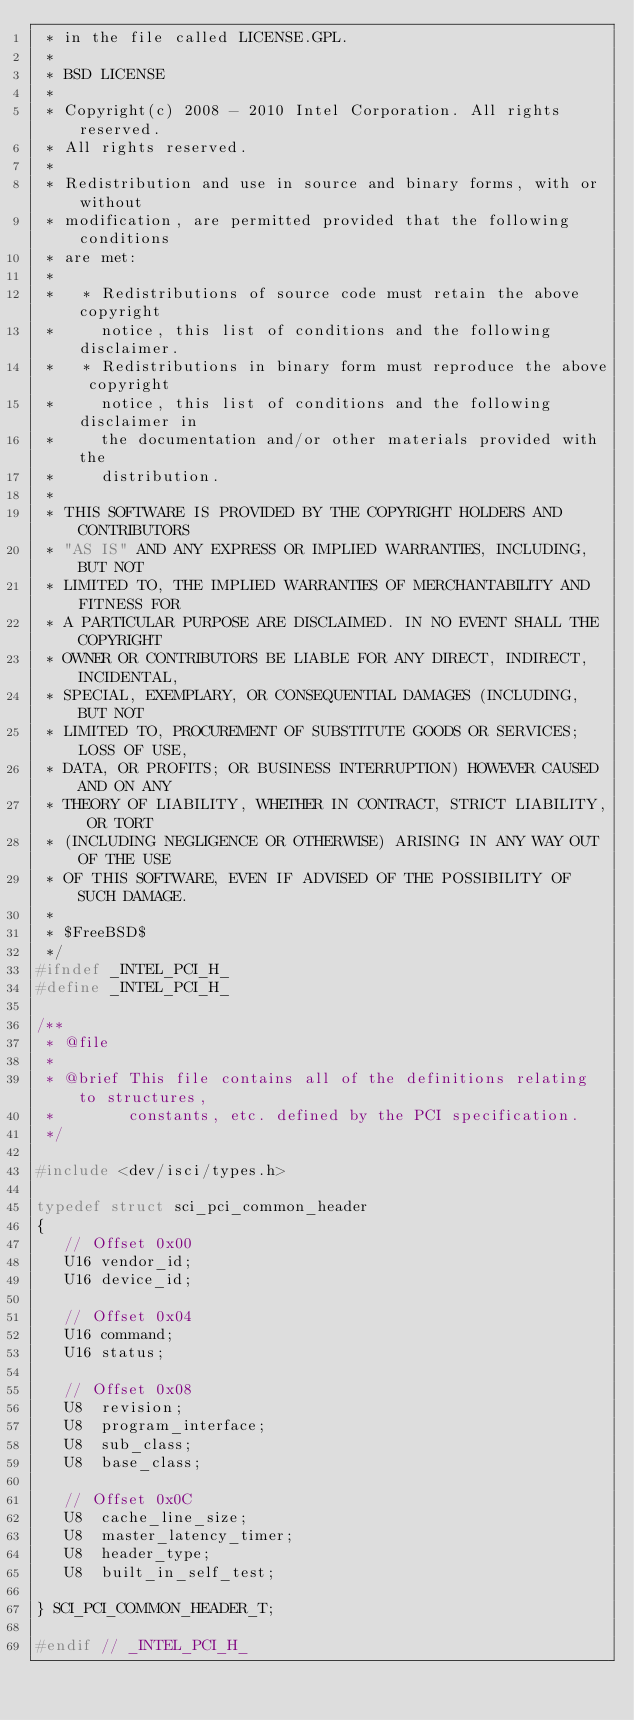Convert code to text. <code><loc_0><loc_0><loc_500><loc_500><_C_> * in the file called LICENSE.GPL.
 *
 * BSD LICENSE
 *
 * Copyright(c) 2008 - 2010 Intel Corporation. All rights reserved.
 * All rights reserved.
 *
 * Redistribution and use in source and binary forms, with or without
 * modification, are permitted provided that the following conditions
 * are met:
 *
 *   * Redistributions of source code must retain the above copyright
 *     notice, this list of conditions and the following disclaimer.
 *   * Redistributions in binary form must reproduce the above copyright
 *     notice, this list of conditions and the following disclaimer in
 *     the documentation and/or other materials provided with the
 *     distribution.
 *
 * THIS SOFTWARE IS PROVIDED BY THE COPYRIGHT HOLDERS AND CONTRIBUTORS
 * "AS IS" AND ANY EXPRESS OR IMPLIED WARRANTIES, INCLUDING, BUT NOT
 * LIMITED TO, THE IMPLIED WARRANTIES OF MERCHANTABILITY AND FITNESS FOR
 * A PARTICULAR PURPOSE ARE DISCLAIMED. IN NO EVENT SHALL THE COPYRIGHT
 * OWNER OR CONTRIBUTORS BE LIABLE FOR ANY DIRECT, INDIRECT, INCIDENTAL,
 * SPECIAL, EXEMPLARY, OR CONSEQUENTIAL DAMAGES (INCLUDING, BUT NOT
 * LIMITED TO, PROCUREMENT OF SUBSTITUTE GOODS OR SERVICES; LOSS OF USE,
 * DATA, OR PROFITS; OR BUSINESS INTERRUPTION) HOWEVER CAUSED AND ON ANY
 * THEORY OF LIABILITY, WHETHER IN CONTRACT, STRICT LIABILITY, OR TORT
 * (INCLUDING NEGLIGENCE OR OTHERWISE) ARISING IN ANY WAY OUT OF THE USE
 * OF THIS SOFTWARE, EVEN IF ADVISED OF THE POSSIBILITY OF SUCH DAMAGE.
 *
 * $FreeBSD$
 */
#ifndef _INTEL_PCI_H_
#define _INTEL_PCI_H_

/**
 * @file
 *
 * @brief This file contains all of the definitions relating to structures,
 *        constants, etc. defined by the PCI specification.
 */

#include <dev/isci/types.h>

typedef struct sci_pci_common_header
{
   // Offset 0x00
   U16 vendor_id;
   U16 device_id;

   // Offset 0x04
   U16 command;
   U16 status;

   // Offset 0x08
   U8  revision;
   U8  program_interface;
   U8  sub_class;
   U8  base_class;

   // Offset 0x0C
   U8  cache_line_size;
   U8  master_latency_timer;
   U8  header_type;
   U8  built_in_self_test;

} SCI_PCI_COMMON_HEADER_T;

#endif // _INTEL_PCI_H_
</code> 